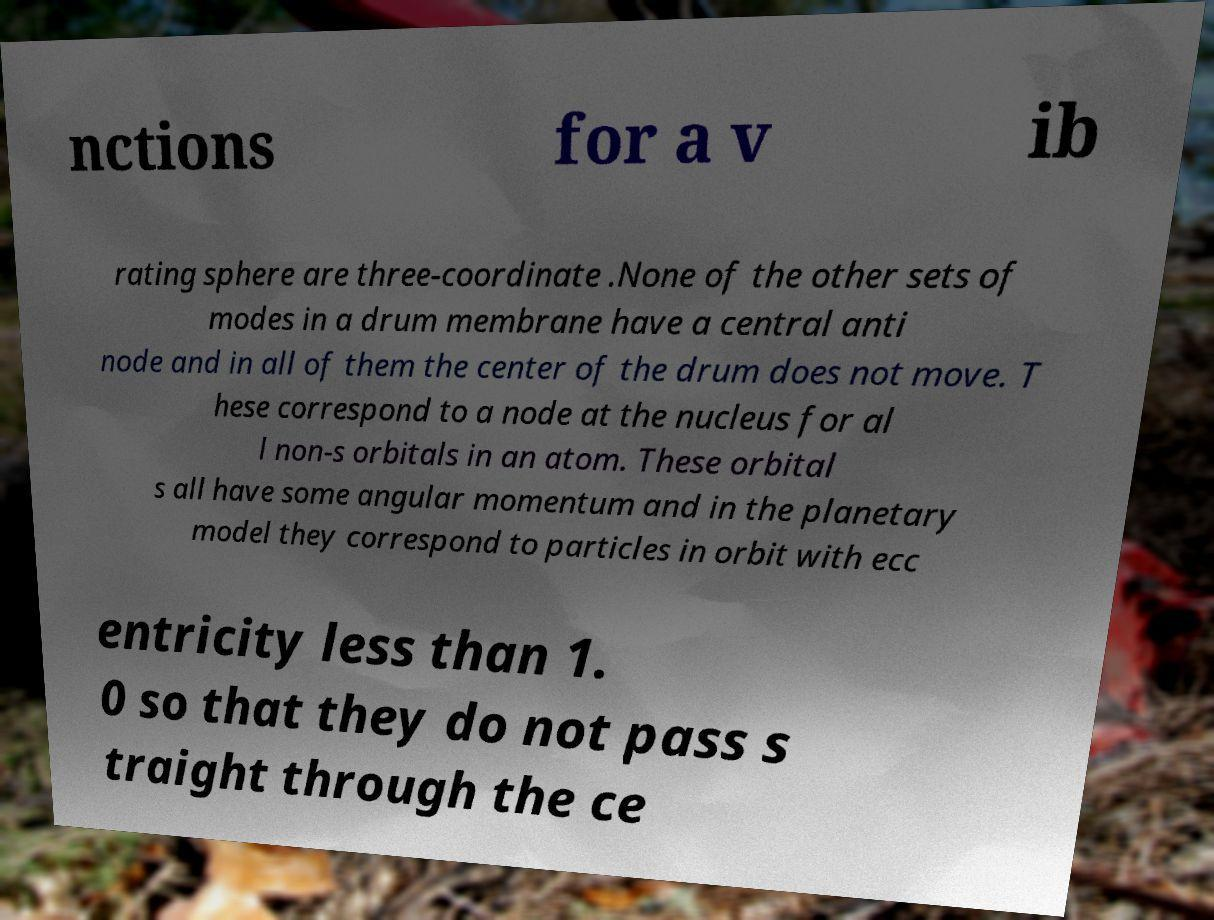Can you accurately transcribe the text from the provided image for me? nctions for a v ib rating sphere are three-coordinate .None of the other sets of modes in a drum membrane have a central anti node and in all of them the center of the drum does not move. T hese correspond to a node at the nucleus for al l non-s orbitals in an atom. These orbital s all have some angular momentum and in the planetary model they correspond to particles in orbit with ecc entricity less than 1. 0 so that they do not pass s traight through the ce 